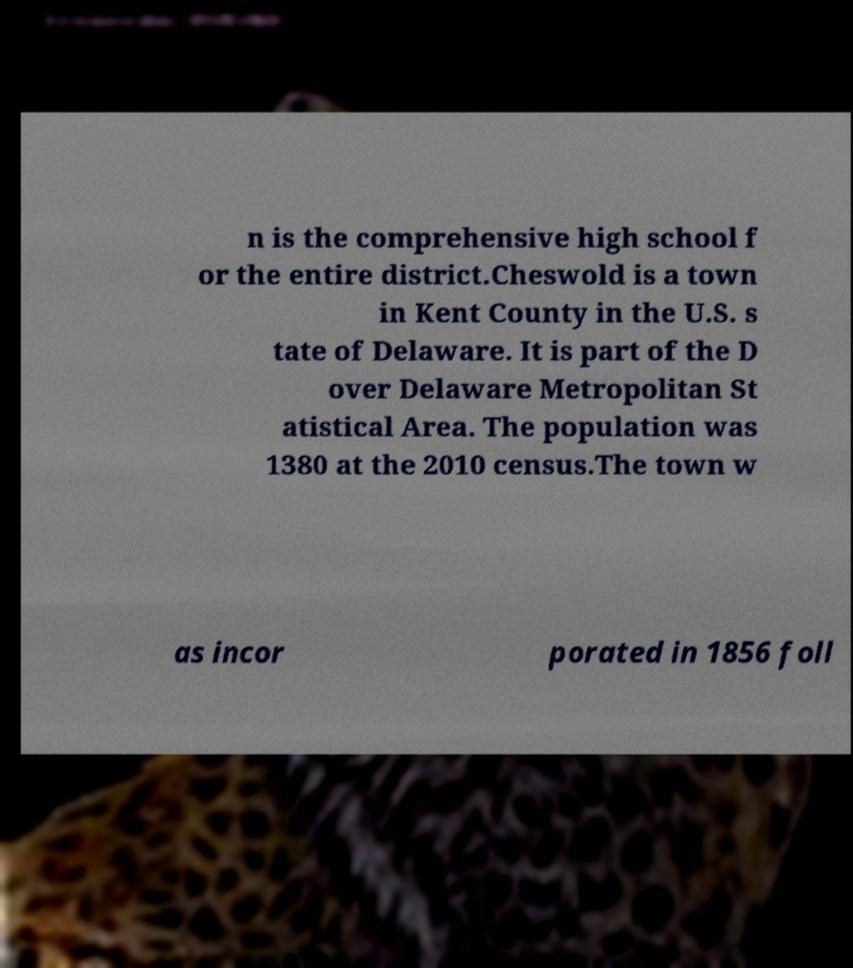Please read and relay the text visible in this image. What does it say? n is the comprehensive high school f or the entire district.Cheswold is a town in Kent County in the U.S. s tate of Delaware. It is part of the D over Delaware Metropolitan St atistical Area. The population was 1380 at the 2010 census.The town w as incor porated in 1856 foll 